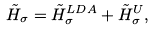Convert formula to latex. <formula><loc_0><loc_0><loc_500><loc_500>\tilde { H } _ { \sigma } = \tilde { H } _ { \sigma } ^ { L D A } + \tilde { H } ^ { U } _ { \sigma } ,</formula> 